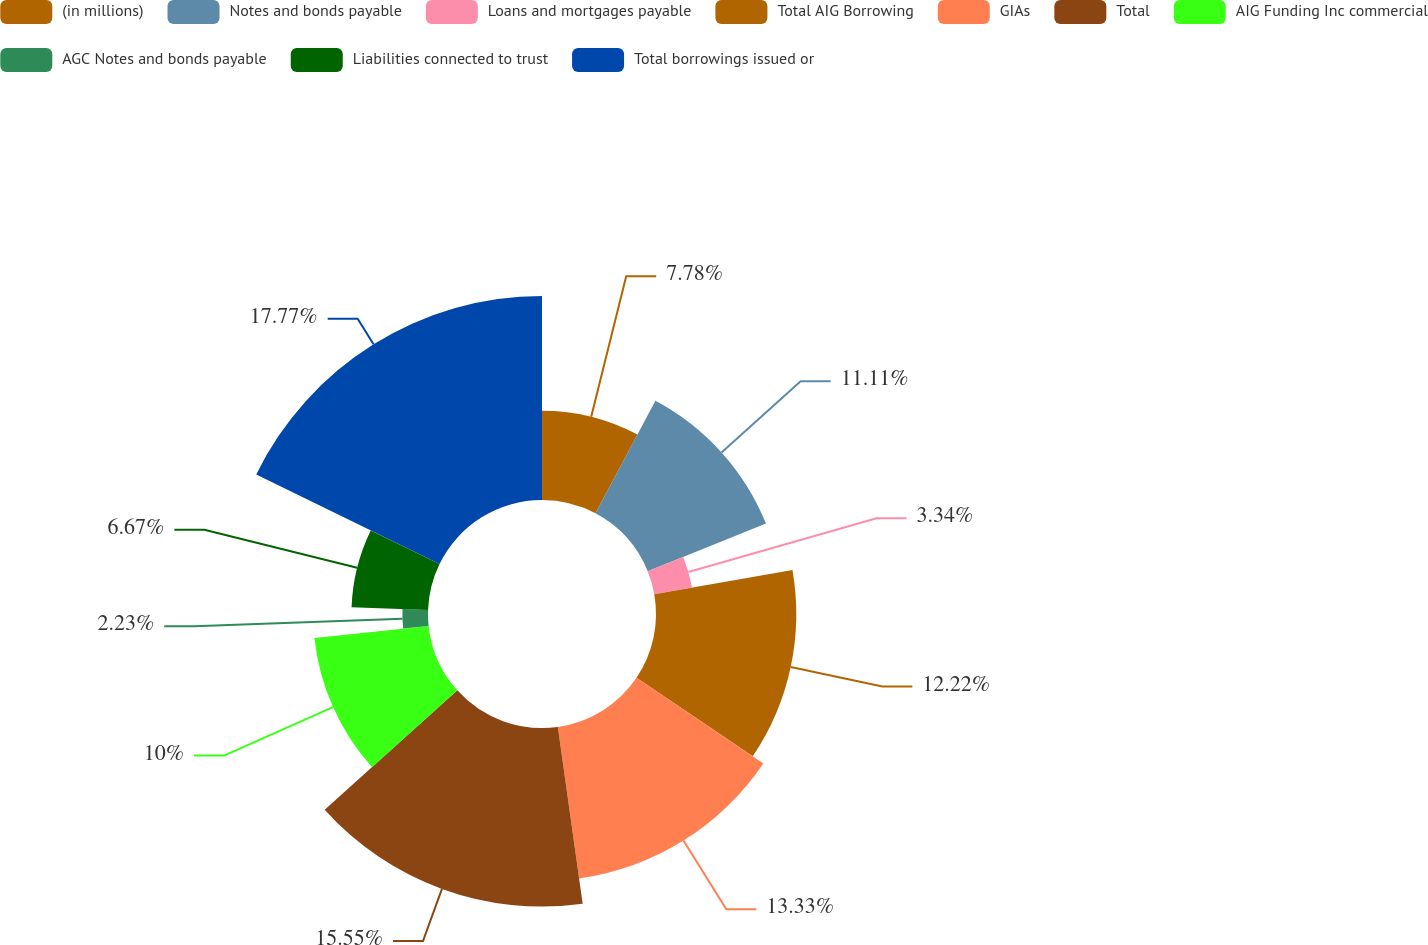Convert chart. <chart><loc_0><loc_0><loc_500><loc_500><pie_chart><fcel>(in millions)<fcel>Notes and bonds payable<fcel>Loans and mortgages payable<fcel>Total AIG Borrowing<fcel>GIAs<fcel>Total<fcel>AIG Funding Inc commercial<fcel>AGC Notes and bonds payable<fcel>Liabilities connected to trust<fcel>Total borrowings issued or<nl><fcel>7.78%<fcel>11.11%<fcel>3.34%<fcel>12.22%<fcel>13.33%<fcel>15.55%<fcel>10.0%<fcel>2.23%<fcel>6.67%<fcel>17.77%<nl></chart> 